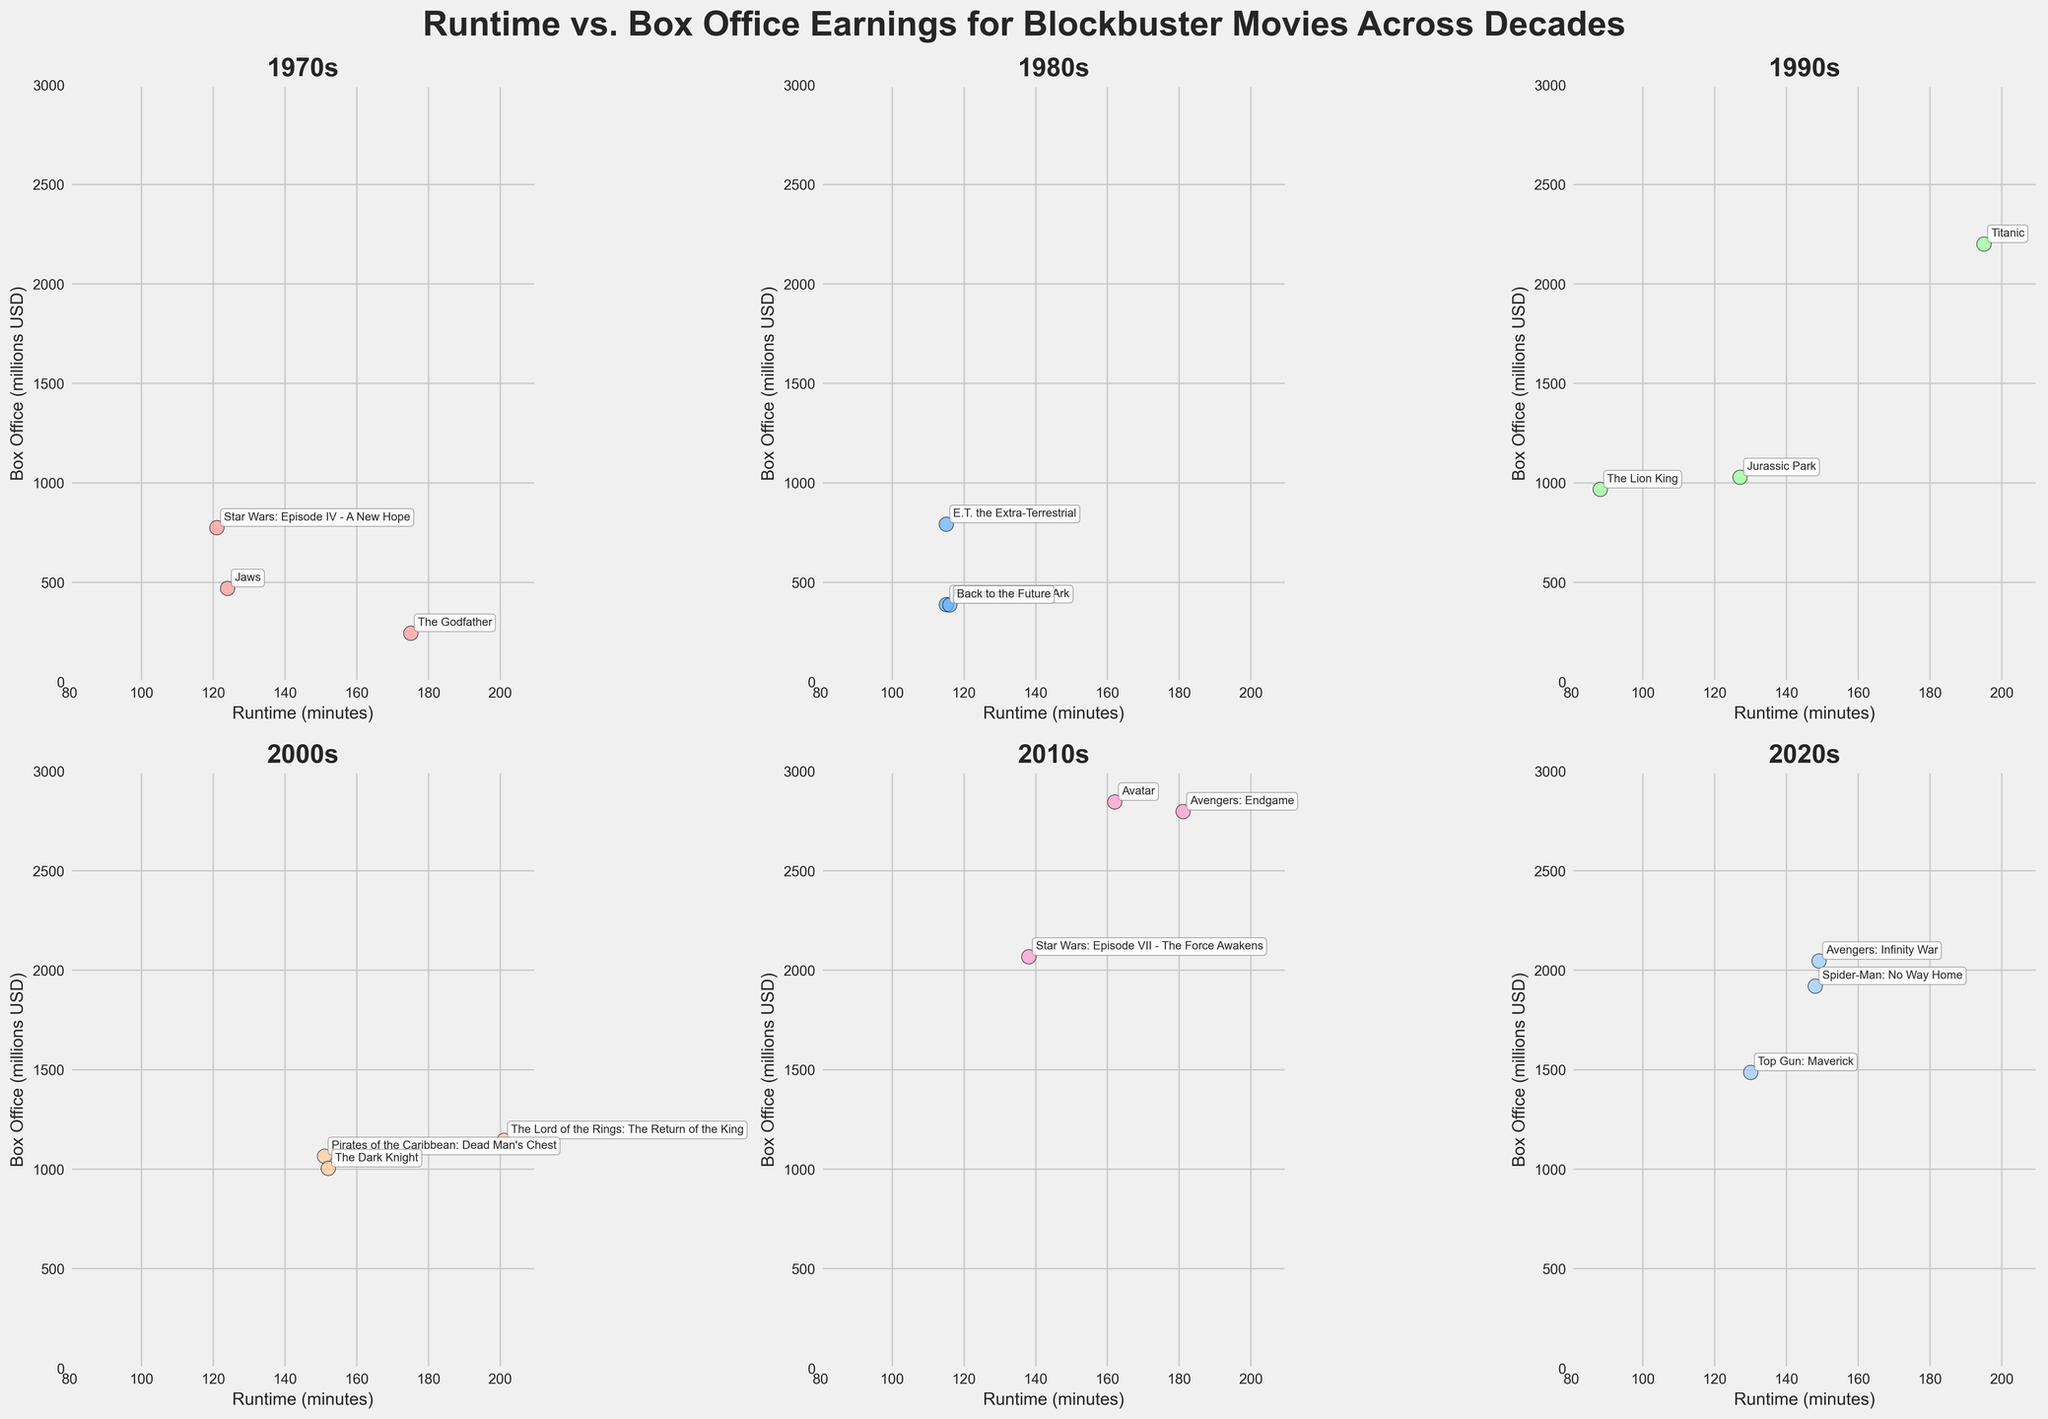How many data points are there for each decade? There are six subplots corresponding to each decade. By counting the number of scatter points in each subplot, we see: 3 for 1970s; 3 for 1980s; 3 for 1990s; 3 for 2000s; 3 for 2010s; and 3 for 2020s. Each decade has 3 data points.
Answer: 3 Which movie has the longest runtime, and in which decade does it fall? By looking through each subplot, "The Lord of the Rings: The Return of the King" is the movie with the longest runtime at 201 minutes. This falls in the 2000s decade.
Answer: The Lord of the Rings: The Return of the King, 2000s Which decade has the highest grossing movie, and what is that movie? Across all plots, the highest point on the y-axis represents the movie with the highest box office earnings. "Avatar" has the highest earnings at 2847 million USD, which falls in the 2010s decade.
Answer: 2010s, Avatar What is the average box office earnings for movies in the 1990s? By looking at the subplot for 1990s, we identify the box office earnings: 1029, 2201, and 968 million USD. Sum these values (1029 + 2201 + 968 = 4198) and then divide by 3 to get the average (4198 / 3).
Answer: 1399.33 million USD In which decade does the movie with the shortest runtime appear, and what is the runtime? By checking all decades' plots, the shortest runtime is 88 minutes, which belongs to "The Lion King" in the 1990s.
Answer: 1990s, 88 minutes 